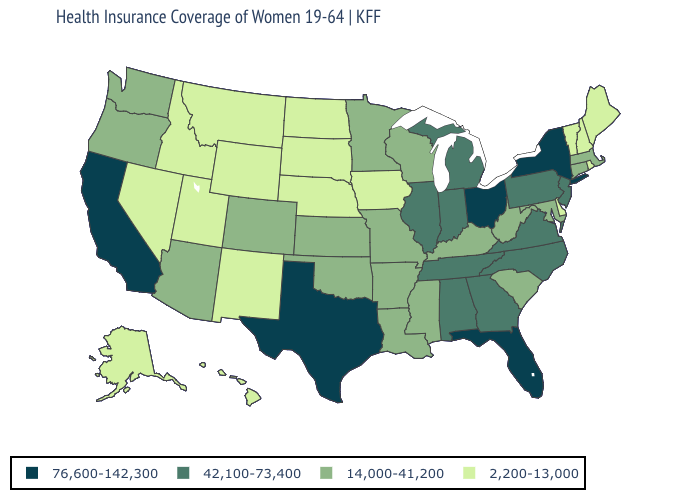What is the lowest value in states that border Missouri?
Concise answer only. 2,200-13,000. Name the states that have a value in the range 14,000-41,200?
Short answer required. Arizona, Arkansas, Colorado, Connecticut, Kansas, Kentucky, Louisiana, Maryland, Massachusetts, Minnesota, Mississippi, Missouri, Oklahoma, Oregon, South Carolina, Washington, West Virginia, Wisconsin. What is the value of Wisconsin?
Concise answer only. 14,000-41,200. Does Vermont have the highest value in the Northeast?
Write a very short answer. No. Among the states that border Delaware , which have the highest value?
Give a very brief answer. New Jersey, Pennsylvania. Among the states that border Alabama , does Florida have the highest value?
Give a very brief answer. Yes. What is the value of New Mexico?
Short answer required. 2,200-13,000. What is the highest value in the USA?
Answer briefly. 76,600-142,300. Name the states that have a value in the range 76,600-142,300?
Write a very short answer. California, Florida, New York, Ohio, Texas. Does the map have missing data?
Answer briefly. No. Is the legend a continuous bar?
Short answer required. No. Is the legend a continuous bar?
Keep it brief. No. What is the value of Nevada?
Be succinct. 2,200-13,000. Name the states that have a value in the range 14,000-41,200?
Quick response, please. Arizona, Arkansas, Colorado, Connecticut, Kansas, Kentucky, Louisiana, Maryland, Massachusetts, Minnesota, Mississippi, Missouri, Oklahoma, Oregon, South Carolina, Washington, West Virginia, Wisconsin. How many symbols are there in the legend?
Concise answer only. 4. 